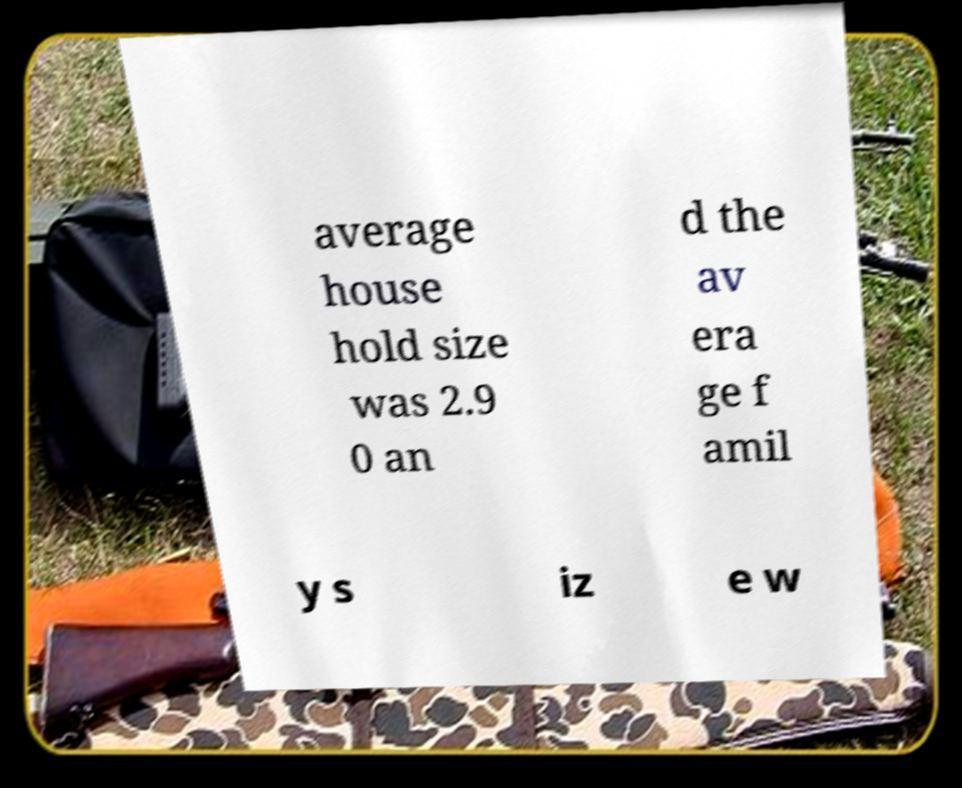Can you accurately transcribe the text from the provided image for me? average house hold size was 2.9 0 an d the av era ge f amil y s iz e w 